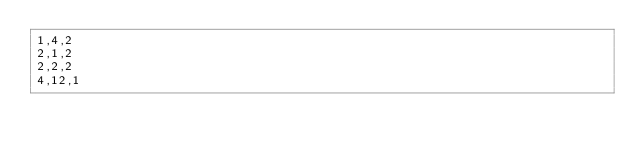<code> <loc_0><loc_0><loc_500><loc_500><_C_>1,4,2
2,1,2
2,2,2
4,12,1
</code> 